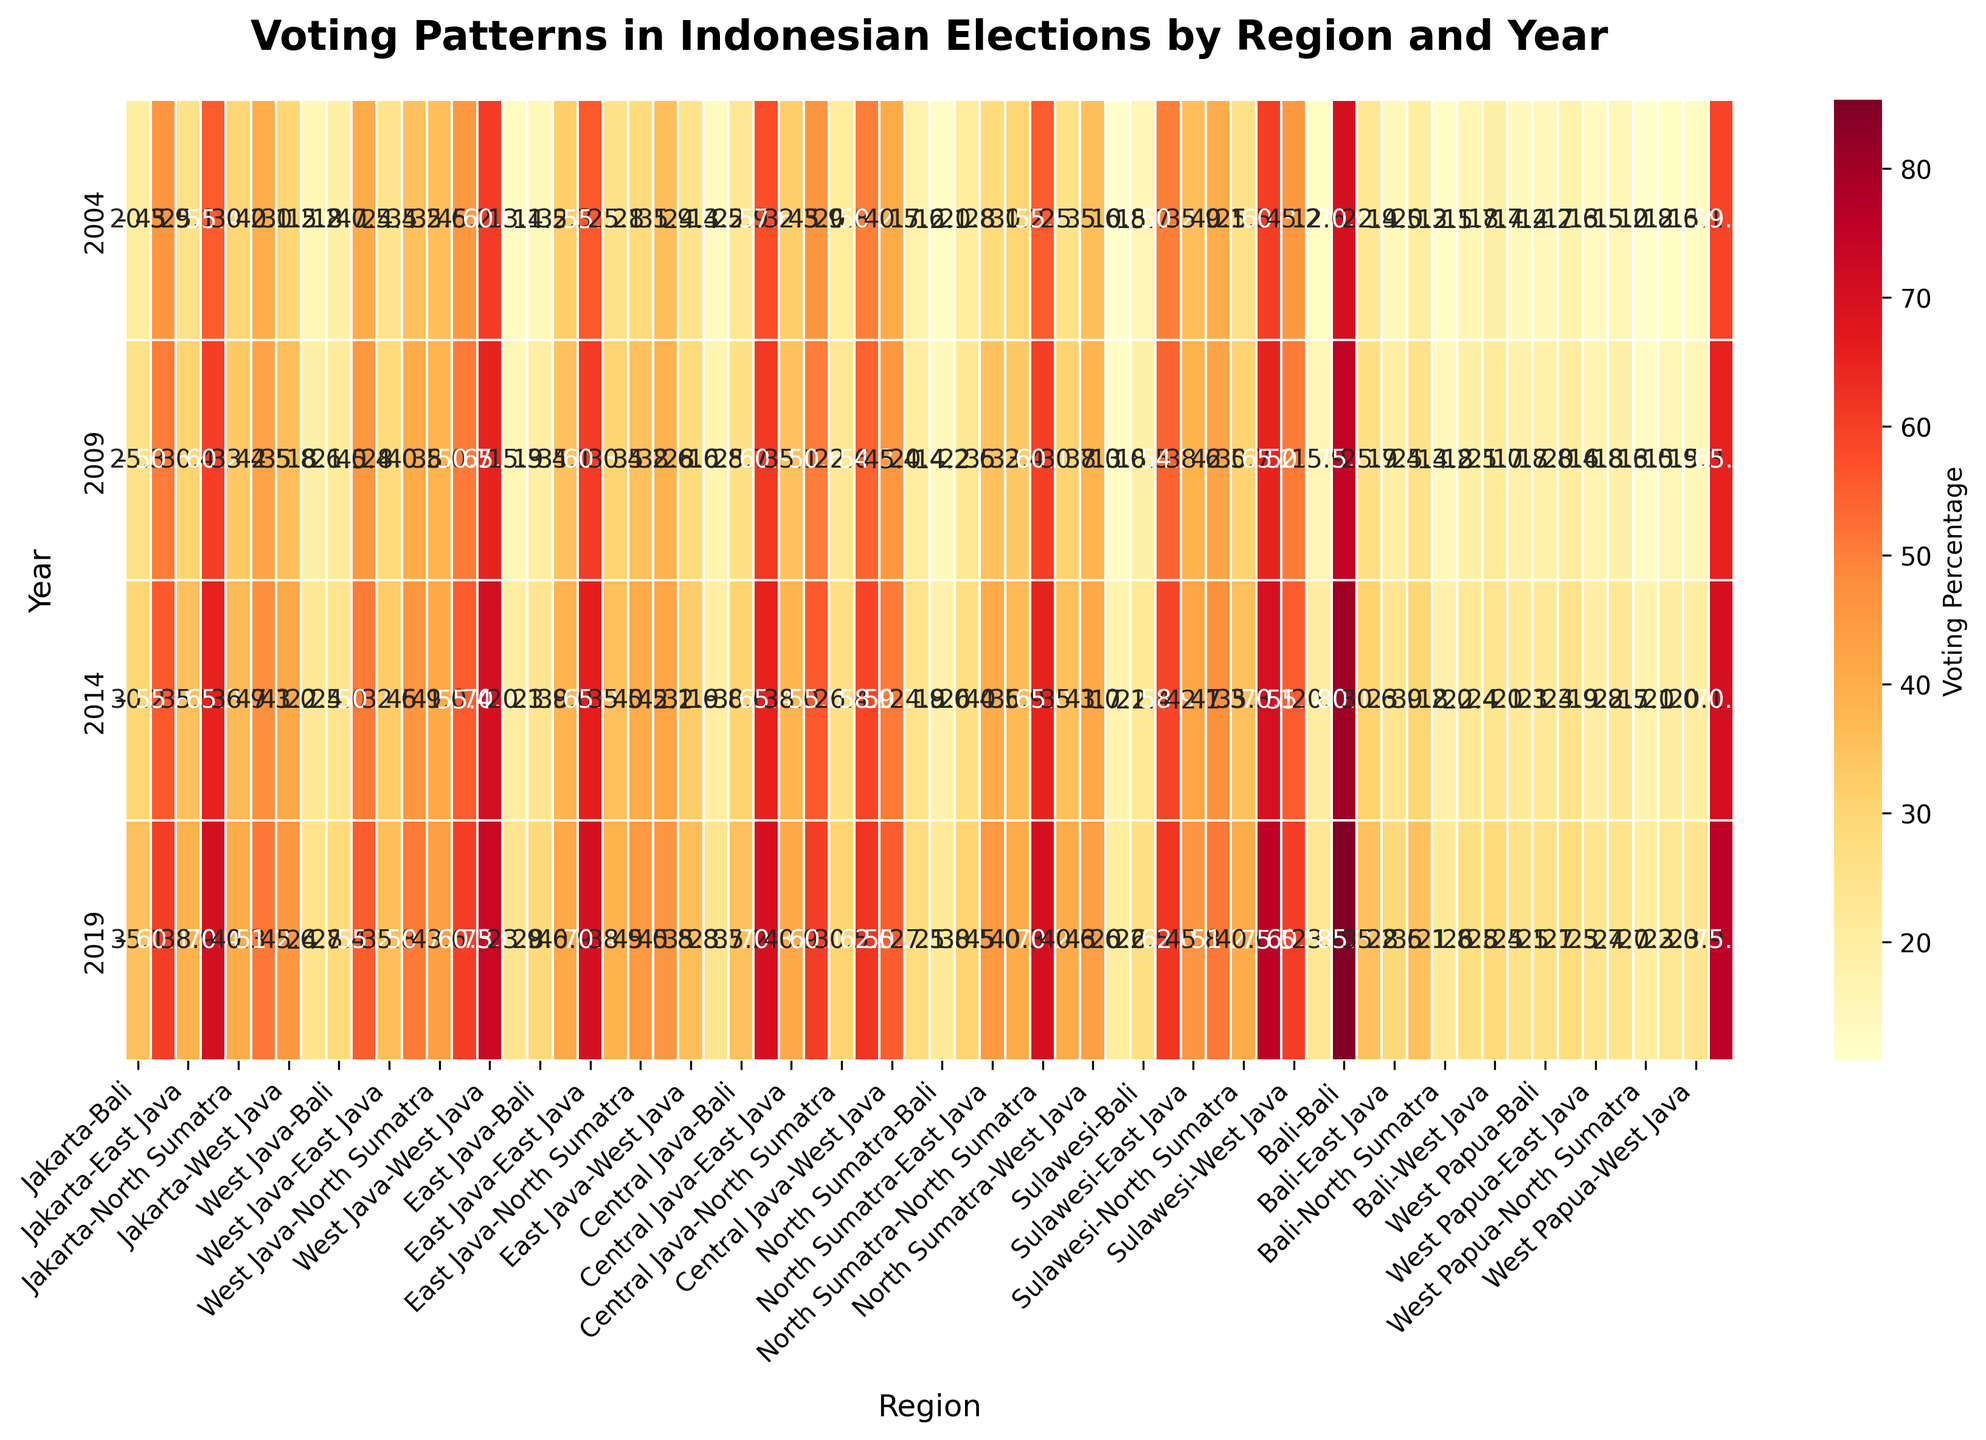What is the title of the figure? The title is usually written at the top of the plot. From there, we can read the title directly.
Answer: Voting Patterns in Indonesian Elections by Region and Year What does the x-axis represent? The x-axis represents the regions. This can be inferred from the labels along the x-axis.
Answer: Regions In which year did Jakarta have the highest voting percentage? By examining the heatmap data for Jakarta across different years, we look for the highest value and see it occurred in 2019.
Answer: 2019 Which region had the highest voting percentage in 2004? We look at the data for the year 2004 across all regions and identify the highest percentage value, which is for Sulawesi.
Answer: Sulawesi What is the general trend in Jakarta's voting percentage from 2004 to 2019? By following the values for Jakarta from 2004 to 2019, we can see that the voting percentage steadily increased.
Answer: Increasing How did the voting percentage in Bali change from 2004 to 2019? By comparing the voting percentages for Bali in 2004 and 2019, we can see the percentage increased from 70.4 to 85.3.
Answer: Increased What is the difference in voting percentage between East Java and West Java in 2014? We subtract the voting percentage of West Java (70.2) from that of East Java (65.9) in 2014 to get the difference.
Answer: -4.3 Which region had the smallest change in voting percentage between 2009 and 2019? We calculate the difference in voting percentages for all regions between 2009 and 2019, and find West Papua had the smallest change.
Answer: West Papua How does the voting pattern in Central Java compare to North Sumatra in 2009? By comparing the percentages for Central Java and North Sumatra in 2009, we notice that Central Java has consistently higher voting percentages.
Answer: Central Java is higher Which two regions had the most significant increase in voting percentage between 2004 and 2019? By calculating the difference in voting percentages for all regions between 2004 and 2019, we find Bali and Jakarta had the most significant increases.
Answer: Bali and Jakarta 